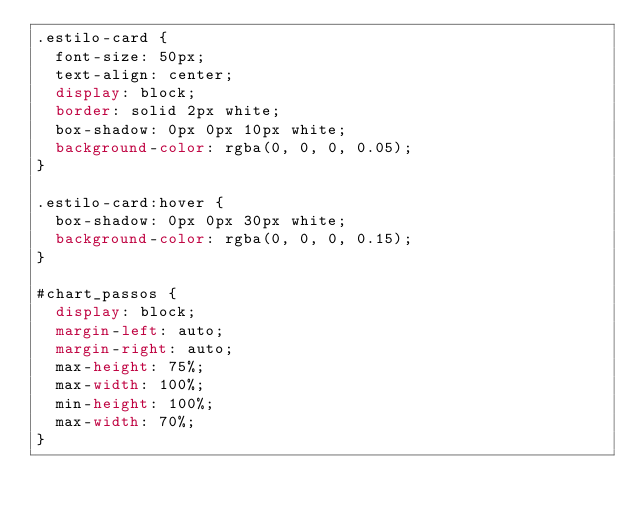<code> <loc_0><loc_0><loc_500><loc_500><_CSS_>.estilo-card {
  font-size: 50px;
  text-align: center;
  display: block;
  border: solid 2px white;
  box-shadow: 0px 0px 10px white;
  background-color: rgba(0, 0, 0, 0.05);
}

.estilo-card:hover {
	box-shadow: 0px 0px 30px white;
  background-color: rgba(0, 0, 0, 0.15);
}

#chart_passos {
	display: block;
	margin-left: auto;
	margin-right: auto;
	max-height: 75%;
	max-width: 100%;
	min-height: 100%;
	max-width: 70%;
}</code> 